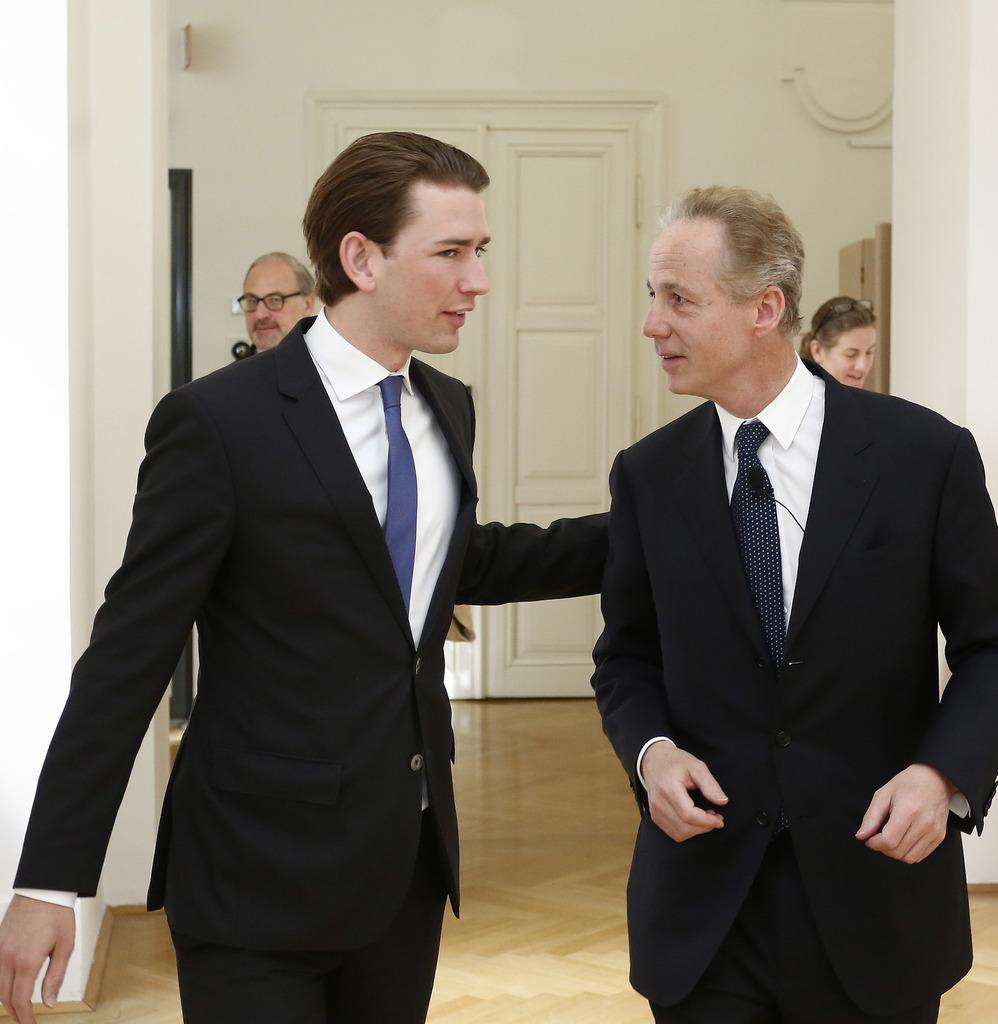How would you summarize this image in a sentence or two? In this picture I can see there are two people walking here and they are wearing a blazer, shirt and tie and in the backdrop there is a man on top left, he has spectacles. There is a woman into right and she also has spectacles. In the backdrop there is a wall and there is a door. 